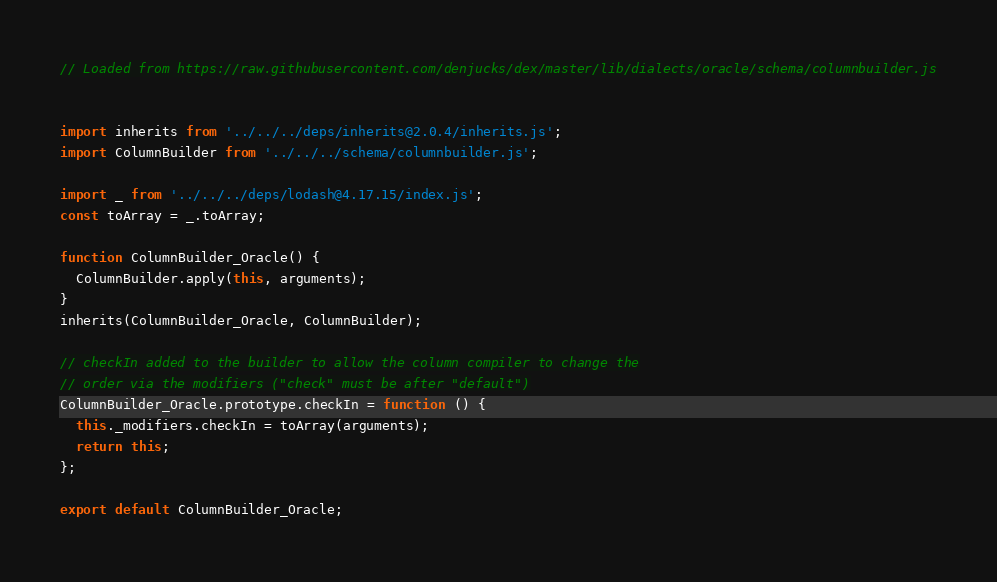Convert code to text. <code><loc_0><loc_0><loc_500><loc_500><_TypeScript_>// Loaded from https://raw.githubusercontent.com/denjucks/dex/master/lib/dialects/oracle/schema/columnbuilder.js


import inherits from '../../../deps/inherits@2.0.4/inherits.js';
import ColumnBuilder from '../../../schema/columnbuilder.js';

import _ from '../../../deps/lodash@4.17.15/index.js';
const toArray = _.toArray;

function ColumnBuilder_Oracle() {
  ColumnBuilder.apply(this, arguments);
}
inherits(ColumnBuilder_Oracle, ColumnBuilder);

// checkIn added to the builder to allow the column compiler to change the
// order via the modifiers ("check" must be after "default")
ColumnBuilder_Oracle.prototype.checkIn = function () {
  this._modifiers.checkIn = toArray(arguments);
  return this;
};

export default ColumnBuilder_Oracle;
</code> 